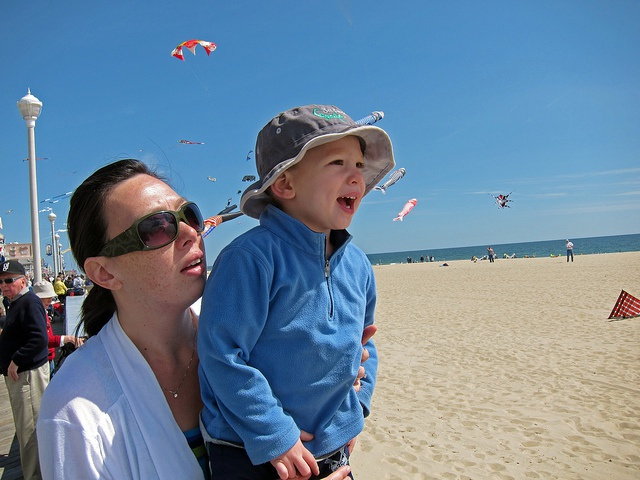Describe the objects in this image and their specific colors. I can see people in gray, darkblue, blue, navy, and black tones, people in gray, black, and brown tones, people in gray, black, and darkgray tones, people in gray, lightgray, maroon, and black tones, and kite in gray, brown, maroon, and black tones in this image. 